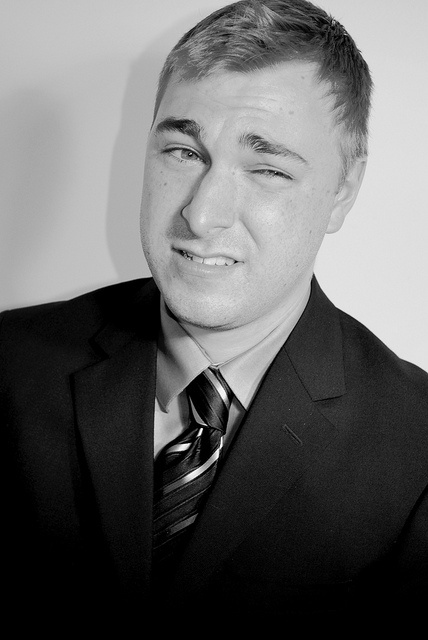Describe the objects in this image and their specific colors. I can see people in black, lightgray, darkgray, and gray tones and tie in lightgray, black, gray, and darkgray tones in this image. 